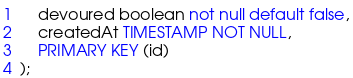<code> <loc_0><loc_0><loc_500><loc_500><_SQL_>    devoured boolean not null default false,
    createdAt TIMESTAMP NOT NULL,
    PRIMARY KEY (id)
);
</code> 